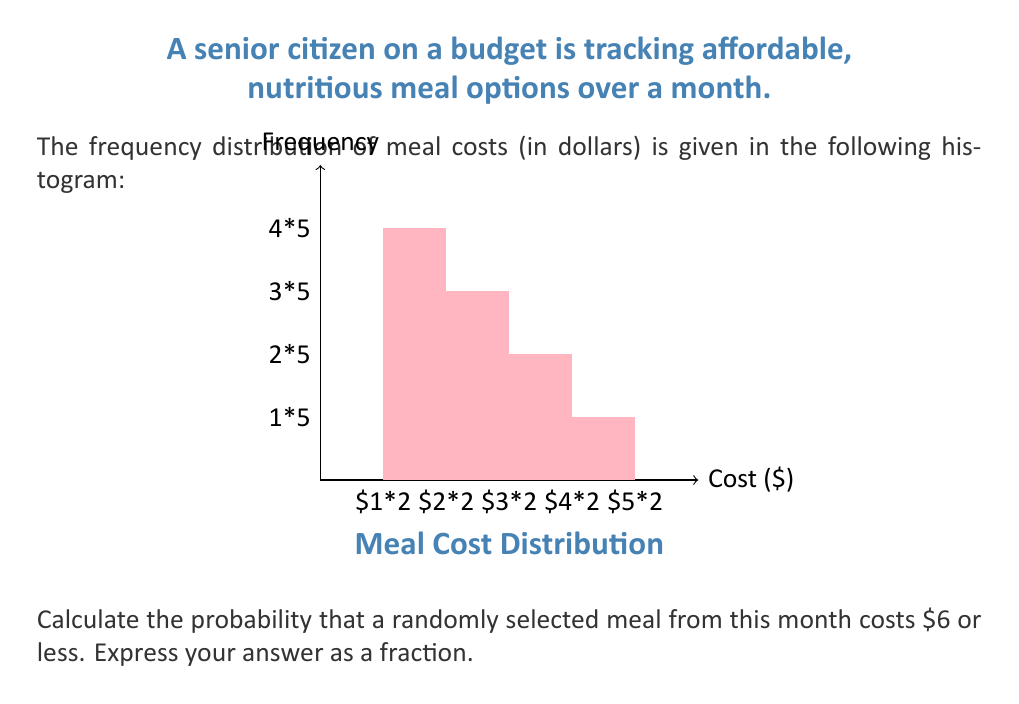What is the answer to this math problem? To solve this problem, we'll follow these steps:

1) First, let's identify the total number of meals:
   $$20 + 15 + 10 + 5 = 50$$ total meals

2) Now, we need to determine how many meals cost $6 or less:
   - $0-$2 range: 20 meals
   - $2-$4 range: 15 meals
   - $4-$6 range: 10 meals
   
   $$20 + 15 + 10 = 45$$ meals cost $6 or less

3) The probability is calculated by dividing the number of favorable outcomes by the total number of possible outcomes:

   $$P(\text{meal costs } \$6 \text{ or less}) = \frac{\text{number of meals } \$6 \text{ or less}}{\text{total number of meals}}$$

   $$P(\text{meal costs } \$6 \text{ or less}) = \frac{45}{50}$$

4) This fraction can be reduced:
   $$\frac{45}{50} = \frac{9}{10}$$

Therefore, the probability that a randomly selected meal costs $6 or less is $\frac{9}{10}$.
Answer: $\frac{9}{10}$ 